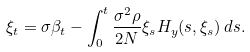<formula> <loc_0><loc_0><loc_500><loc_500>\xi _ { t } = \sigma \beta _ { t } - \int _ { 0 } ^ { t } \frac { \sigma ^ { 2 } \rho } { 2 N } \xi _ { s } H _ { y } ( s , \xi _ { s } ) \, d s .</formula> 